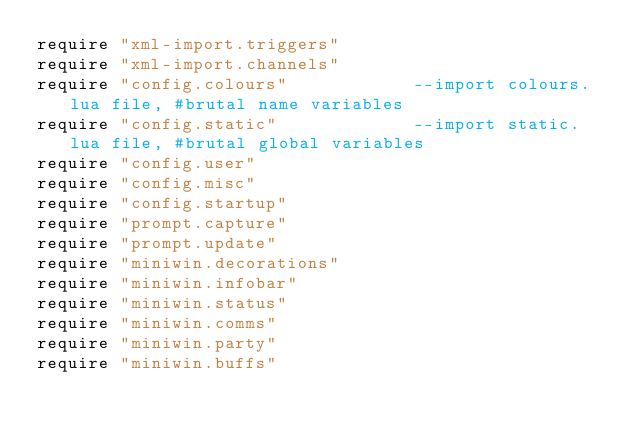Convert code to text. <code><loc_0><loc_0><loc_500><loc_500><_Lua_>require "xml-import.triggers"
require "xml-import.channels"
require "config.colours"            --import colours.lua file, #brutal name variables
require "config.static"             --import static.lua file, #brutal global variables
require "config.user"
require "config.misc"
require "config.startup"
require "prompt.capture"
require "prompt.update"
require "miniwin.decorations"
require "miniwin.infobar"
require "miniwin.status"
require "miniwin.comms"
require "miniwin.party"
require "miniwin.buffs"
</code> 